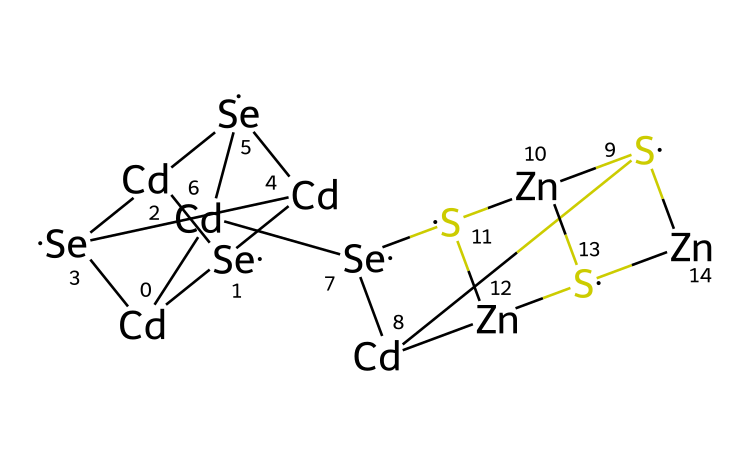What is the main metal component in this quantum dot? The SMILES representation indicates the presence of cadmium, which is denoted by [Cd].
Answer: cadmium How many selenium atoms are present in this structure? In the SMILES notation, the [Se] appears five times, signifying five selenium atoms in total.
Answer: five What is the overall charge of the quantum dot based on the components? The SMILES does not indicate any charge carriers or anions/cations, hence it is neutral.
Answer: neutral Which two additional elements are included besides cadmium and selenium? The presence of zinc, denoted by [Zn], and sulfur, denoted by [S], indicates these additional elements are included.
Answer: zinc and sulfur How many distinct types of atoms are present in the quantum dot? The chemical structure includes four distinct types: cadmium, selenium, zinc, and sulfur.
Answer: four What type of nanoparticles are represented by this chemical structure? This structure corresponds to semiconductor nanoparticles, commonly known as quantum dots.
Answer: quantum dots What is the role of sulfur in the molecular framework of this quantum dot? Sulfur often acts as a stabilizing center or linker in quantum dots, contributing to the structural integrity and function.
Answer: stabilizing agent 